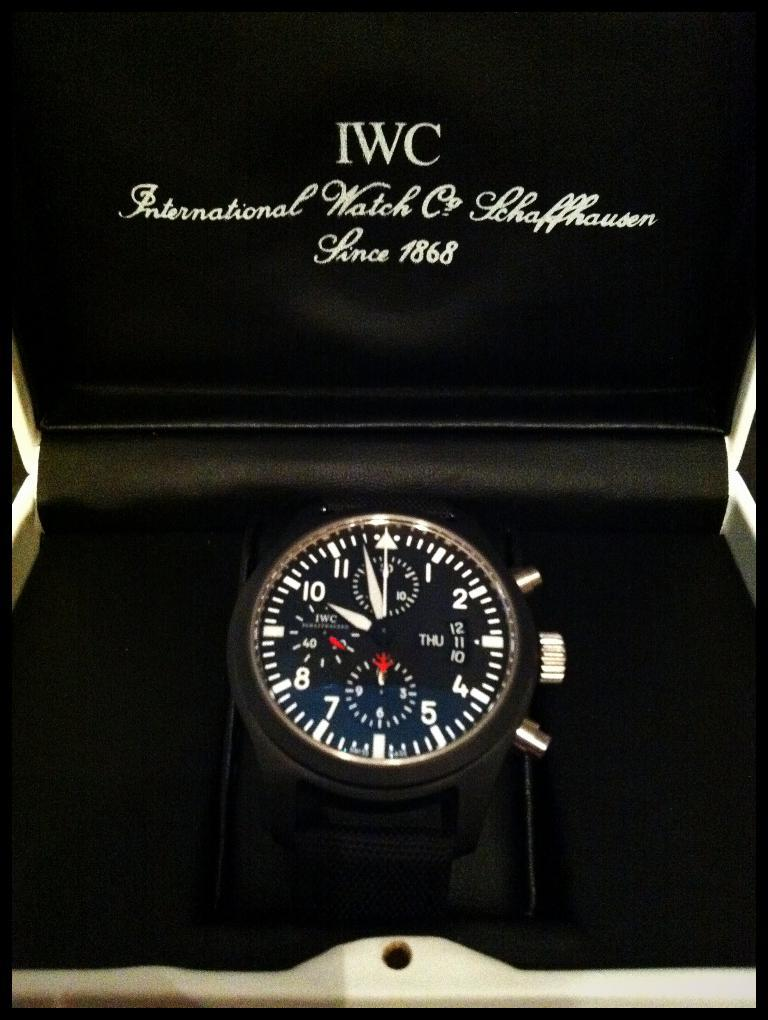What object is the main focus of the image? There is a watch in the image. How is the watch being stored or displayed? The watch is placed in a box. What can be seen on the box besides the watch? There is text and numbers on the box. What feature surrounds the image? The image has borders. What type of food is being served in the image? There is no food present in the image; it features a watch placed in a box. Can you tell me how many tickets are visible in the image? There are no tickets present in the image; it features a watch placed in a box. 